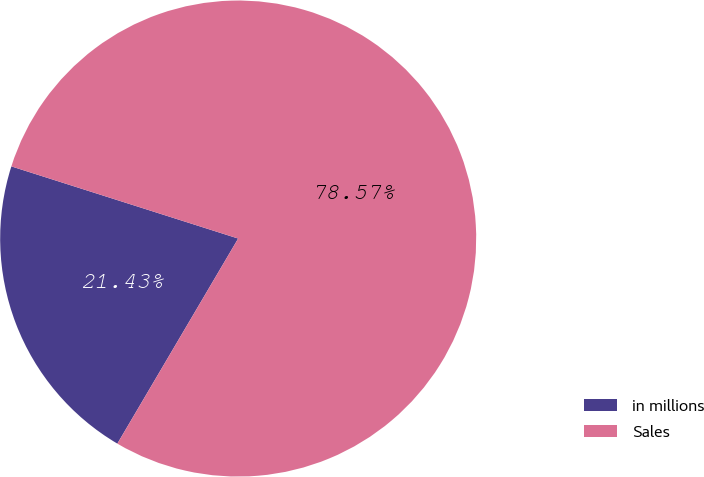Convert chart. <chart><loc_0><loc_0><loc_500><loc_500><pie_chart><fcel>in millions<fcel>Sales<nl><fcel>21.43%<fcel>78.57%<nl></chart> 